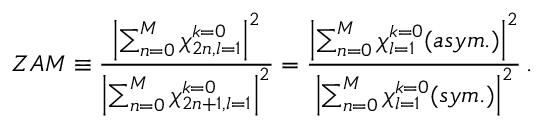Convert formula to latex. <formula><loc_0><loc_0><loc_500><loc_500>Z A M \equiv \frac { \left | \sum _ { n = 0 } ^ { M } { \chi _ { 2 n , l = 1 } ^ { k = 0 } } \right | ^ { 2 } } { \left | \sum _ { n = 0 } ^ { M } { \chi _ { 2 n + 1 , l = 1 } ^ { k = 0 } } \right | ^ { 2 } } = \frac { \left | \sum _ { n = 0 } ^ { M } { \chi _ { l = 1 } ^ { k = 0 } ( a s y m . ) } \right | ^ { 2 } } { \left | \sum _ { n = 0 } ^ { M } { \chi _ { l = 1 } ^ { k = 0 } ( s y m . ) } \right | ^ { 2 } } \, .</formula> 